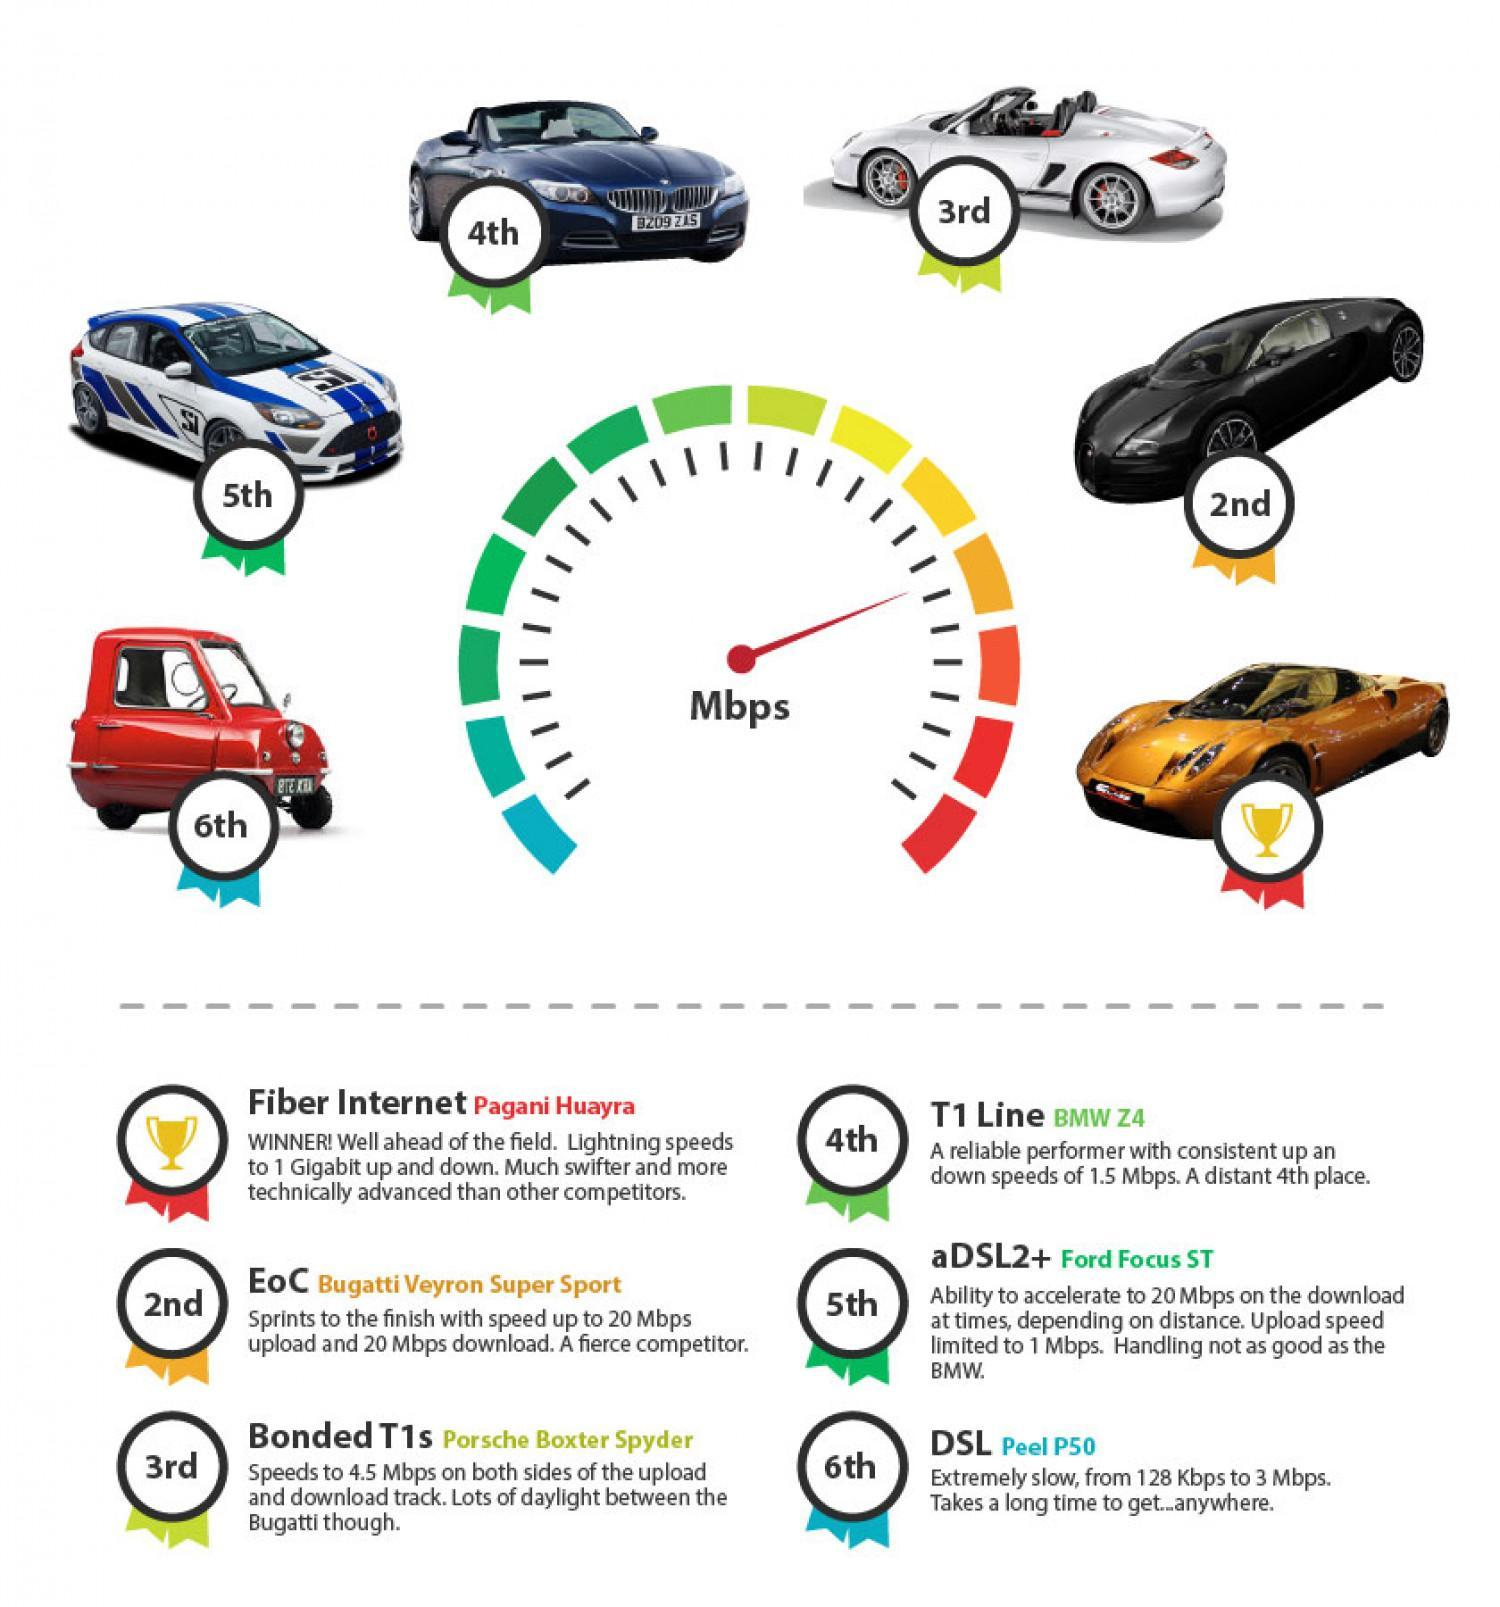What is the name of the white car in the image?
Answer the question with a short phrase. Porsche Boxter Spyder How many internet service providers are top performers in terms of speed? 6 Which service provider has a down speed of 20Mbps, EoC, aDSL2+, or DSL? EoC Which car represents the internet service provider having the highest speed for download and uploads? Pagani Huayra Which service provider is represented by the black car in the image? EoC What is the color of the car which is first in terms of speed, red, orange, or black? orange 